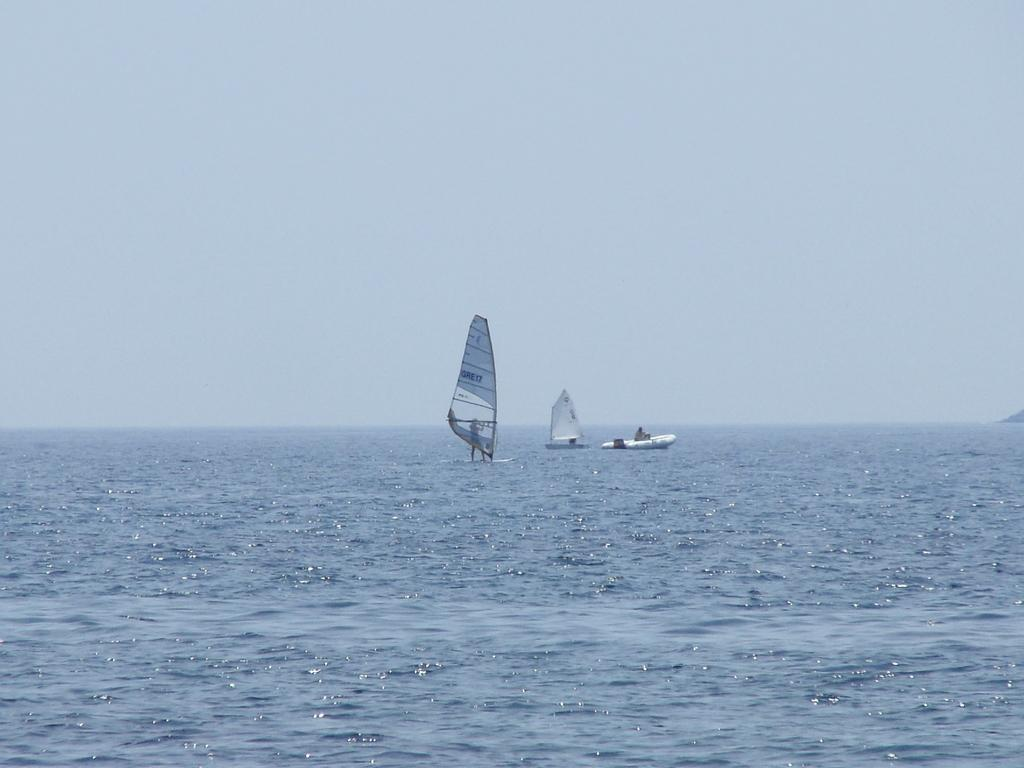How many boats can be seen in the image? There are 3 boats in the image. What are the boats doing in the image? The boats are sailing in the sea. What color is the sky in the image? The sky is blue in the image. What type of crops is the farmer harvesting in the image? There is no farmer or crops present in the image; it features 3 boats sailing in the sea with a blue sky. 